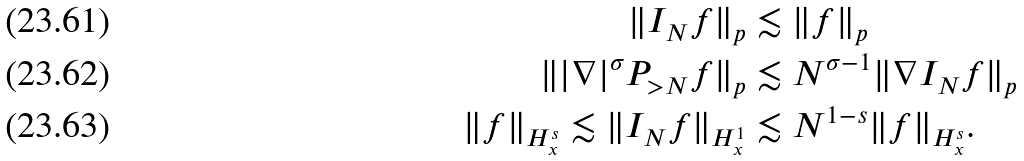<formula> <loc_0><loc_0><loc_500><loc_500>\| I _ { N } f \| _ { p } & \lesssim \| f \| _ { p } \\ \| | \nabla | ^ { \sigma } P _ { > N } f \| _ { p } & \lesssim N ^ { \sigma - 1 } \| \nabla I _ { N } f \| _ { p } \\ \| f \| _ { H ^ { s } _ { x } } \lesssim \| I _ { N } f \| _ { H ^ { 1 } _ { x } } & \lesssim N ^ { 1 - s } \| f \| _ { H ^ { s } _ { x } } .</formula> 